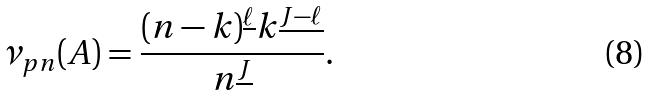<formula> <loc_0><loc_0><loc_500><loc_500>\nu _ { p n } ( A ) = \frac { ( n - k ) ^ { \underline { \ell } } k ^ { \underline { J - \ell } } } { n ^ { \underline { J } } } .</formula> 